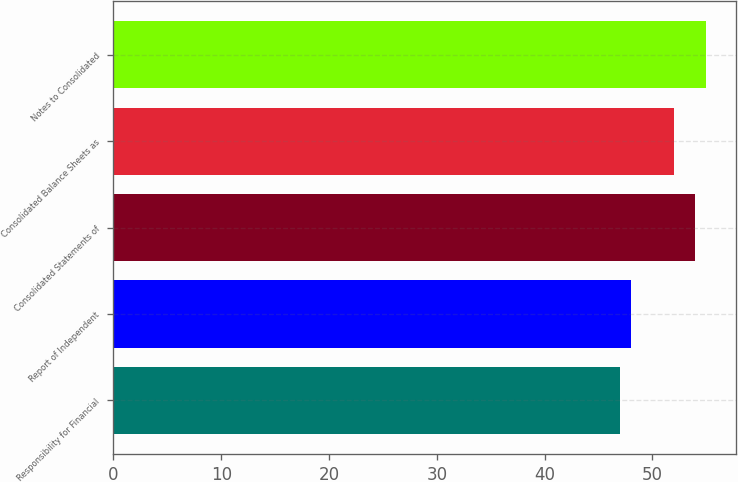<chart> <loc_0><loc_0><loc_500><loc_500><bar_chart><fcel>Responsibility for Financial<fcel>Report of Independent<fcel>Consolidated Statements of<fcel>Consolidated Balance Sheets as<fcel>Notes to Consolidated<nl><fcel>47<fcel>48<fcel>54<fcel>52<fcel>55<nl></chart> 